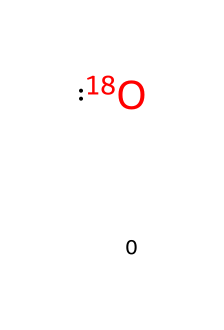What is the atomic mass of the isotope represented here? Oxygen-18 (the isotope shown) has an atomic mass of approximately 18 atomic mass units (amu). By recognizing that the notation [18O] indicates the isotope of oxygen with a mass number of 18, we directly identify its atomic mass.
Answer: 18 amu How many protons does this isotope have? All isotopes of oxygen, including Oxygen-18, have a fixed number of protons, which is 8. This number is derived from the atomic number of oxygen found in the periodic table.
Answer: 8 In which natural occurrences can this isotope be found? Oxygen-18 is commonly found in water (H2O) and carbon dioxide (CO2) in the environment. As a naturally occurring isotope, it exists alongside oxygen-16 in these compounds.
Answer: water and carbon dioxide What is the significance of studying oxygen isotopes in ice cores? Studying oxygen isotopes, particularly the ratios of Oxygen-18 to Oxygen-16 in ice cores, helps scientists infer past temperatures and climate conditions. The variation in these ratios serves as a proxy for historical climate data.
Answer: past temperatures How does the ratio of oxygen isotopes in ice cores relate to past winter conditions? The ratio of Oxygen-18 to Oxygen-16 in ice cores reflects changes in precipitation and temperature over time. Specifically, higher ratios generally indicate warmer temperatures, while lower ratios suggest colder conditions during precipitation events.
Answer: reflect winter temperatures What is the primary method for analyzing oxygen isotopes in ice cores? The primary method used is isotope ratio mass spectrometry (IRMS), which accurately measures the ratios of different isotopes in a sample, enabling climate researchers to derive historical climate data from ice cores.
Answer: isotope ratio mass spectrometry 